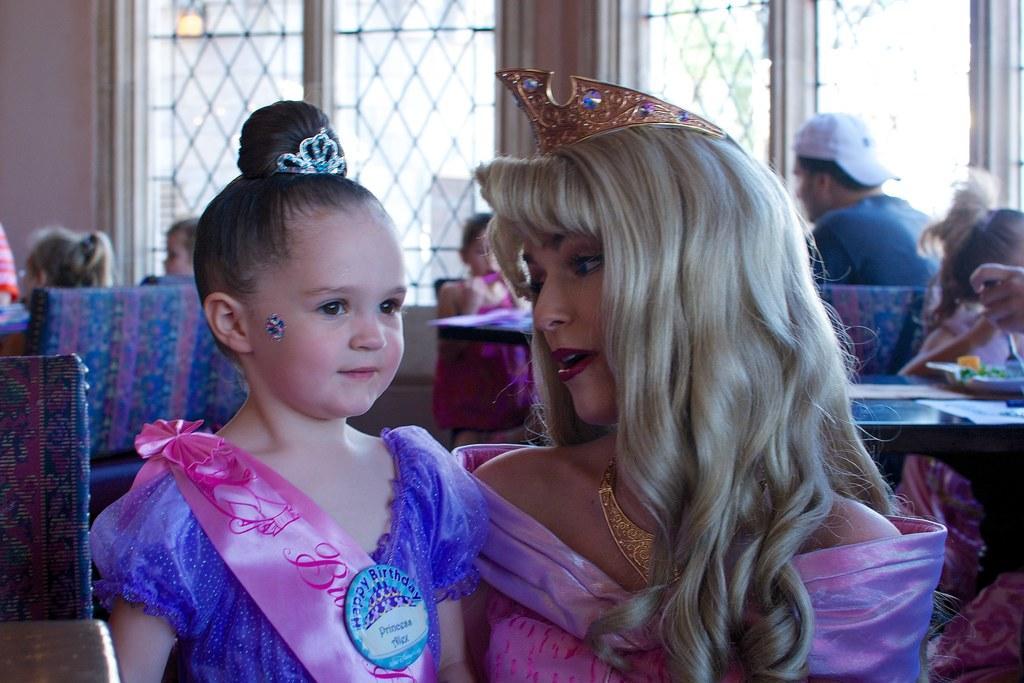Can you describe this image briefly? In this image there is a lady wearing a crown on his head, beside her there is a child, behind them there are a few people sitting on the chairs, in front of them there are tables with some stuff on it. In the background there is a wall and windows. 